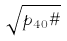Convert formula to latex. <formula><loc_0><loc_0><loc_500><loc_500>\sqrt { p _ { 4 0 } \# }</formula> 